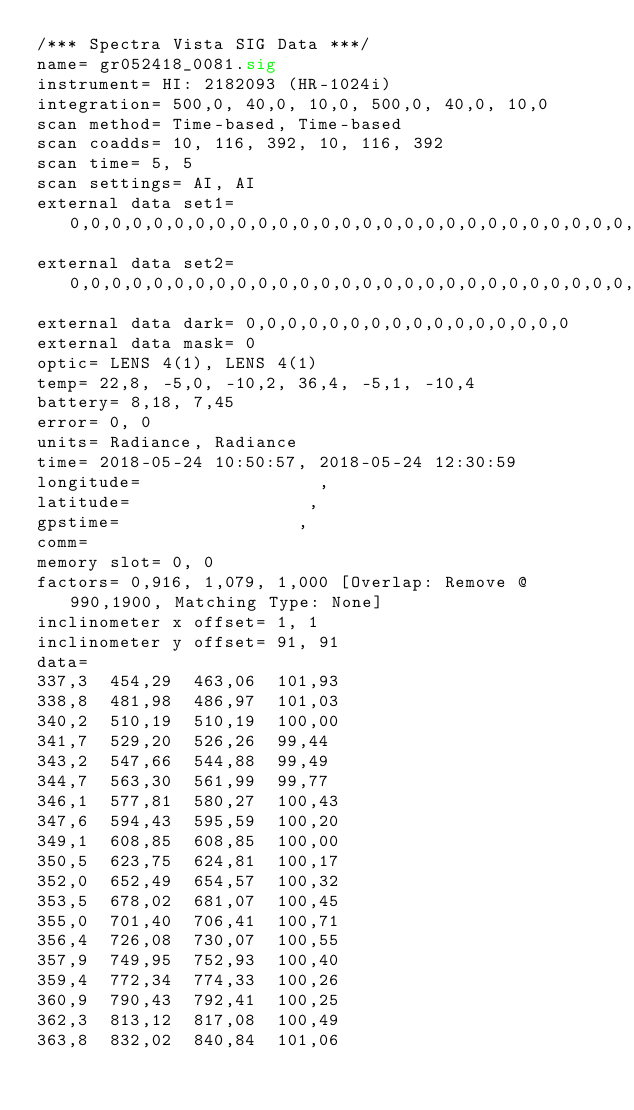Convert code to text. <code><loc_0><loc_0><loc_500><loc_500><_SML_>/*** Spectra Vista SIG Data ***/
name= gr052418_0081.sig
instrument= HI: 2182093 (HR-1024i)
integration= 500,0, 40,0, 10,0, 500,0, 40,0, 10,0
scan method= Time-based, Time-based
scan coadds= 10, 116, 392, 10, 116, 392
scan time= 5, 5
scan settings= AI, AI
external data set1= 0,0,0,0,0,0,0,0,0,0,0,0,0,0,0,0,0,0,0,0,0,0,0,0,0,0,0,0,0,0,0,0
external data set2= 0,0,0,0,0,0,0,0,0,0,0,0,0,0,0,0,0,0,0,0,0,0,0,0,0,0,0,0,0,0,0,0
external data dark= 0,0,0,0,0,0,0,0,0,0,0,0,0,0,0,0
external data mask= 0
optic= LENS 4(1), LENS 4(1)
temp= 22,8, -5,0, -10,2, 36,4, -5,1, -10,4
battery= 8,18, 7,45
error= 0, 0
units= Radiance, Radiance
time= 2018-05-24 10:50:57, 2018-05-24 12:30:59
longitude=                 ,                 
latitude=                 ,                 
gpstime=                 ,                 
comm= 
memory slot= 0, 0
factors= 0,916, 1,079, 1,000 [Overlap: Remove @ 990,1900, Matching Type: None]
inclinometer x offset= 1, 1
inclinometer y offset= 91, 91
data= 
337,3  454,29  463,06  101,93
338,8  481,98  486,97  101,03
340,2  510,19  510,19  100,00
341,7  529,20  526,26  99,44
343,2  547,66  544,88  99,49
344,7  563,30  561,99  99,77
346,1  577,81  580,27  100,43
347,6  594,43  595,59  100,20
349,1  608,85  608,85  100,00
350,5  623,75  624,81  100,17
352,0  652,49  654,57  100,32
353,5  678,02  681,07  100,45
355,0  701,40  706,41  100,71
356,4  726,08  730,07  100,55
357,9  749,95  752,93  100,40
359,4  772,34  774,33  100,26
360,9  790,43  792,41  100,25
362,3  813,12  817,08  100,49
363,8  832,02  840,84  101,06</code> 